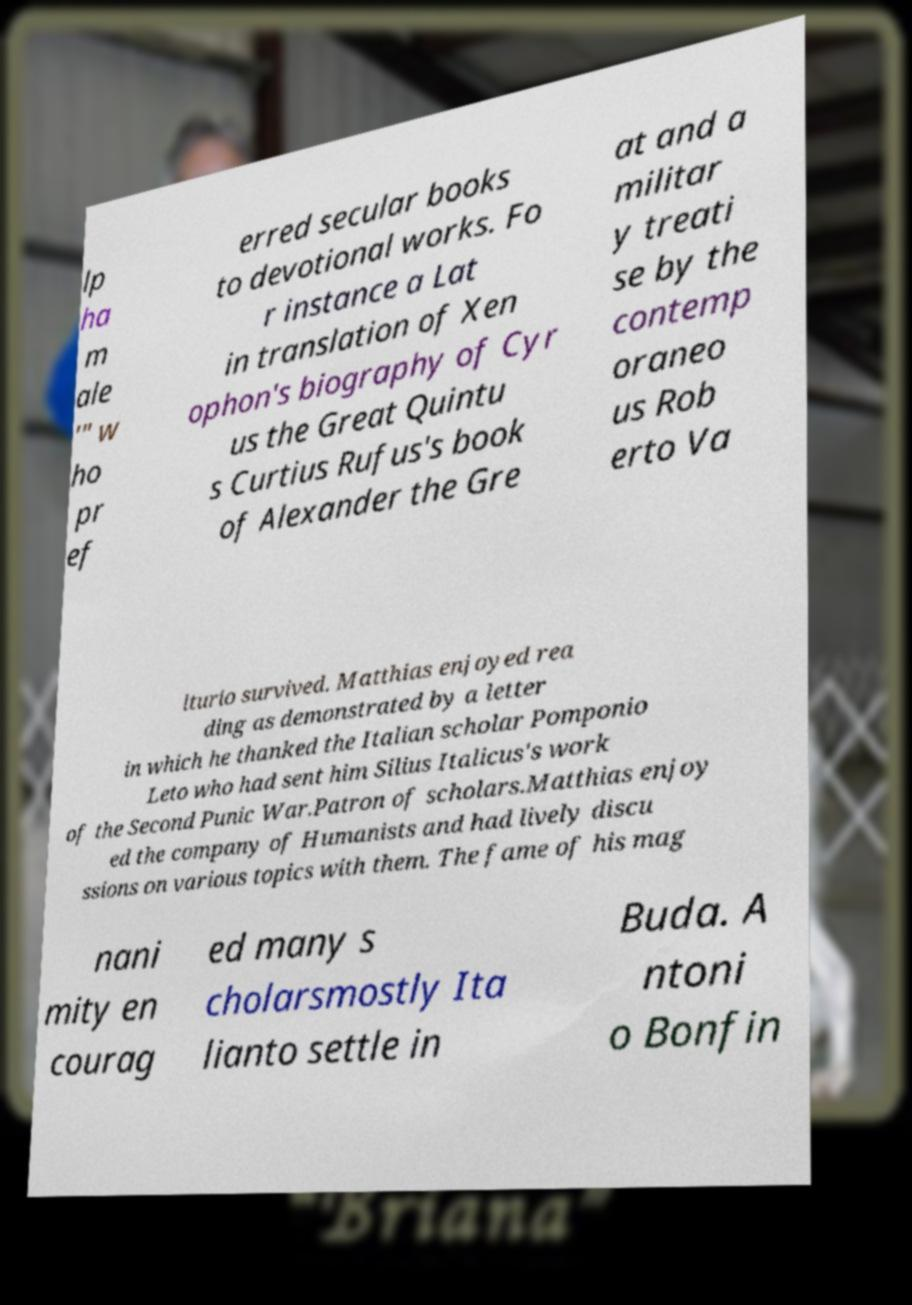Please read and relay the text visible in this image. What does it say? lp ha m ale '" w ho pr ef erred secular books to devotional works. Fo r instance a Lat in translation of Xen ophon's biography of Cyr us the Great Quintu s Curtius Rufus's book of Alexander the Gre at and a militar y treati se by the contemp oraneo us Rob erto Va lturio survived. Matthias enjoyed rea ding as demonstrated by a letter in which he thanked the Italian scholar Pomponio Leto who had sent him Silius Italicus's work of the Second Punic War.Patron of scholars.Matthias enjoy ed the company of Humanists and had lively discu ssions on various topics with them. The fame of his mag nani mity en courag ed many s cholarsmostly Ita lianto settle in Buda. A ntoni o Bonfin 